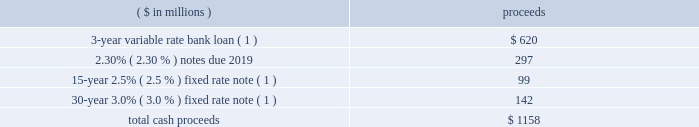Notes to the consolidated financial statements 50 2016 ppg annual report and form 10-k loans will bear interest at rates based , at the company 2019s option , on one of two specified base rates plus a margin based on certain formulas defined in the credit agreement .
Additionally , the credit agreement contains a commitment fee , as defined in the credit agreement , on the amount of unused commitments under the credit agreement ranging from 0.080% ( 0.080 % ) to 0.225% ( 0.225 % ) per annum .
The average commitment fee in 2016 was 0.09% ( 0.09 % ) , and ppg is committed to pay 0.09% ( 0.09 % ) in 2017 .
The credit agreement also supports the company 2019s commercial paper borrowings .
As a result , the commercial paper borrowings as of december 31 , 2015 were classified as long- term debt based on ppg 2019s intent and ability to refinance these borrowings on a long-term basis .
There were no commercial paper borrowings outstanding as of december 31 , 2016 .
The credit agreement contains usual and customary restrictive covenants for facilities of its type , which include , with specified exceptions , limitations on the company 2019s ability to create liens or other encumbrances , to enter into sale and leaseback transactions and to enter into consolidations , mergers or transfers of all or substantially all of its assets .
The credit agreement maintains the same restrictive covenant as the prior credit agreement whereby the company must maintain a ratio of total indebtedness to total capitalization , as defined in the credit agreement , of 60% ( 60 % ) or less .
As of december 31 , 2016 , total indebtedness was 45% ( 45 % ) of the company 2019s total capitalization .
The credit agreement also contains customary events of default , including the failure to make timely payments when due under the credit agreement or other material indebtedness , the failure to satisfy covenants contained in the credit agreement , a change in control of the company and specified events of bankruptcy and insolvency that would permit the lenders to accelerate the repayment of any loans .
In june 2015 , ppg 2019s 20ac300 million 3.875% ( 3.875 % ) notes matured , upon which the company paid $ 336 million to settle these obligations .
In march 2015 , ppg completed a public offering of 20ac600 million 0.875% ( 0.875 % ) notes due 2022 and 20ac600 million 1.400% ( 1.400 % ) notes due 2027 , or 20ac1.2 billion ( $ 1.26 billion ) in aggregate principal amount .
These notes were issued pursuant to ppg 2019s existing shelf registration statement and pursuant to an indenture between the company and the bank of new york mellon trust company , n.a. , as trustee , as supplemented .
The indenture governing these notes contains covenants that limit the company 2019s ability to , among other things , incur certain liens securing indebtedness , engage in certain sale-leaseback transactions , and enter into certain consolidations , mergers , conveyances , transfers or leases of all or substantially all the company 2019s assets .
The terms of these notes also require the company to make an offer to repurchase notes upon a change of control triggering event ( as defined in the indenture ) at a price equal to 101% ( 101 % ) of their principal amount plus accrued and unpaid interest .
The company may issue additional debt from time to time pursuant to the indenture .
The aggregate cash proceeds from the notes , net of discounts and fees , was $ 1.24 billion .
The notes are denominated in euro and have been designated as hedges of net investments in the company 2019s european operations .
For more information , refer to note 9 201cfinancial instruments , hedging activities and fair value measurements . 201d 2014 activities in november 2014 , ppg completed a public offering of $ 300 million in aggregate principal amount of its 2.3% ( 2.3 % ) notes due 2019 .
These notes were issued pursuant to its existing shelf registration statement and pursuant to an indenture between the company and the bank of new york mellon trust company , n.a. , as trustee , as supplemented .
The company may issue additional debt from time to time pursuant to the indenture .
The indenture governing these notes contains covenants that limit the company 2019s ability to , among other things , incur certain liens securing indebtedness , engage in certain sale-leaseback transactions , and enter into certain consolidations , mergers , conveyances , transfers or leases of all or substantially all the company 2019s assets .
The terms of these notes also require the company to make an offer to repurchase notes upon a change of control triggering event ( as defined in the indenture ) at a price equal to 101% ( 101 % ) of their principal amount plus accrued and unpaid interest .
Also in november 2014 , the company entered into three euro-denominated borrowings as follows .
3-year 20ac500 million bank loan interest on this loan is variable and is based on changes to the euribor interest rate .
This loan contains covenants materially consistent with the five-year credit agreement .
At december 31 , 2016 , the average interest rate on this borrowing was 0.31% ( 0.31 % ) .
15-year 20ac80 million 2.5% ( 2.5 % ) fixed interest and 30-year 20ac120 million 3.0% ( 3.0 % ) fixed interest notes ppg privately placed a 15-year 20ac80 million 2.5% ( 2.5 % ) fixed interest note and a 30-year 20ac120 million 3.0% ( 3.0 % ) fixed interest note .
These notes contain covenants materially consistent with the 2.3% ( 2.3 % ) notes discussed above .
The cash proceeds related to these borrowings net of discounts and fees were as follows: .
( 1 ) these debt arrangements are denominated in euro and have been designated as net investment hedges of the company 2019s european operations .
For more information refer to note 9 201cfinancial instruments , hedging activities and fair value measurements . 201d in december 2014 , ppg completed a debt refinancing which included redeeming approximately $ 1.5 billion of public notes and a tender offer for any and all of its outstanding 9% ( 9 % ) debentures , due 2021 and the 7.70% ( 7.70 % ) notes , due 2038 ( together , the 201coffers 201d ) .
The consideration for each $ 1000 principal amount of the 2021 debentures was $ 1334 and was $ 1506 for the 2038 notes .
After the expiration of the offers , ppg accepted for purchase all of the securities that were validly tendered .
An aggregate principal amount of $ 90 million was redeemed .
How much annual interest expense did ppg save by retiring it's 3.875% ( 3.875 % ) notes , in million euros? 
Computations: (300 * 3.875%)
Answer: 11.625. 